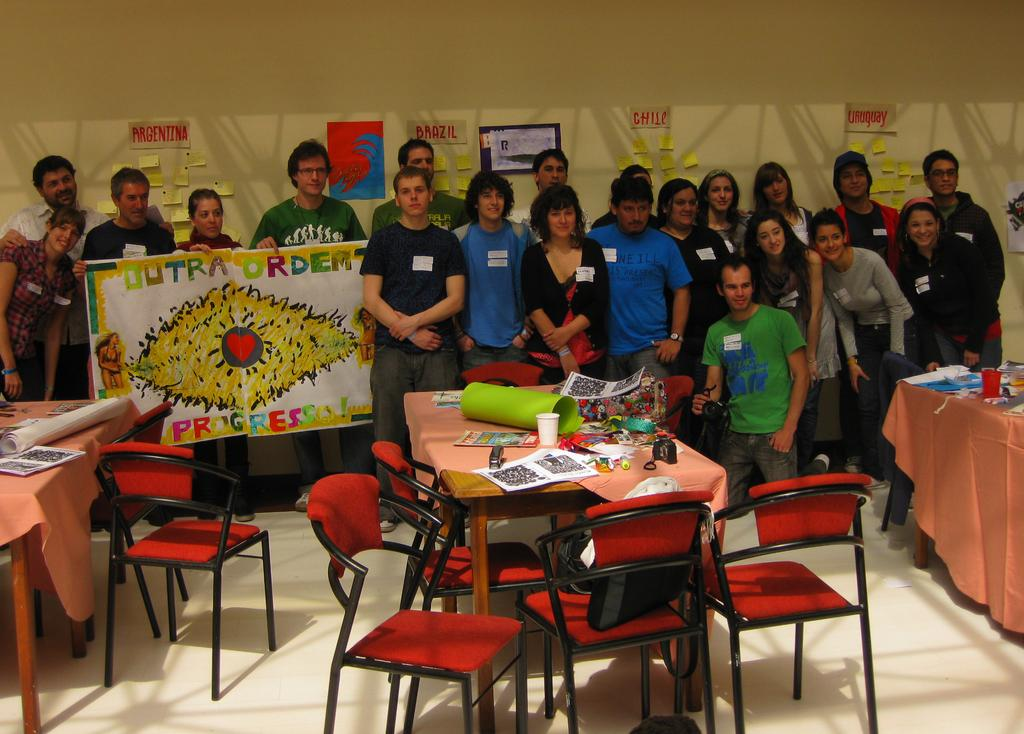What is on the wall in the image? There are posters on the wall in the image. How many persons are visible in the image? There are persons standing in the image. What are three persons doing in the image? Three persons are holding a poster. What can be found on the tables in the image? There are cups, a chart, and other things on the tables. What type of chair is present in the image? There is a red chair in the image. What time is it in the image? The time cannot be determined from the image, as there is no clock or any indication of the time of day. What team is represented by the persons holding the poster? There is no indication of a team in the image; the persons are simply holding a poster. 